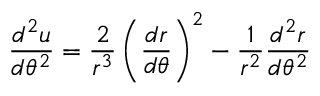<formula> <loc_0><loc_0><loc_500><loc_500>{ \frac { d ^ { 2 } u } { d \theta ^ { 2 } } } = { \frac { 2 } { r ^ { 3 } } } \left ( { \frac { d r } { d \theta } } \right ) ^ { 2 } - { \frac { 1 } { r ^ { 2 } } } { \frac { d ^ { 2 } r } { d \theta ^ { 2 } } }</formula> 